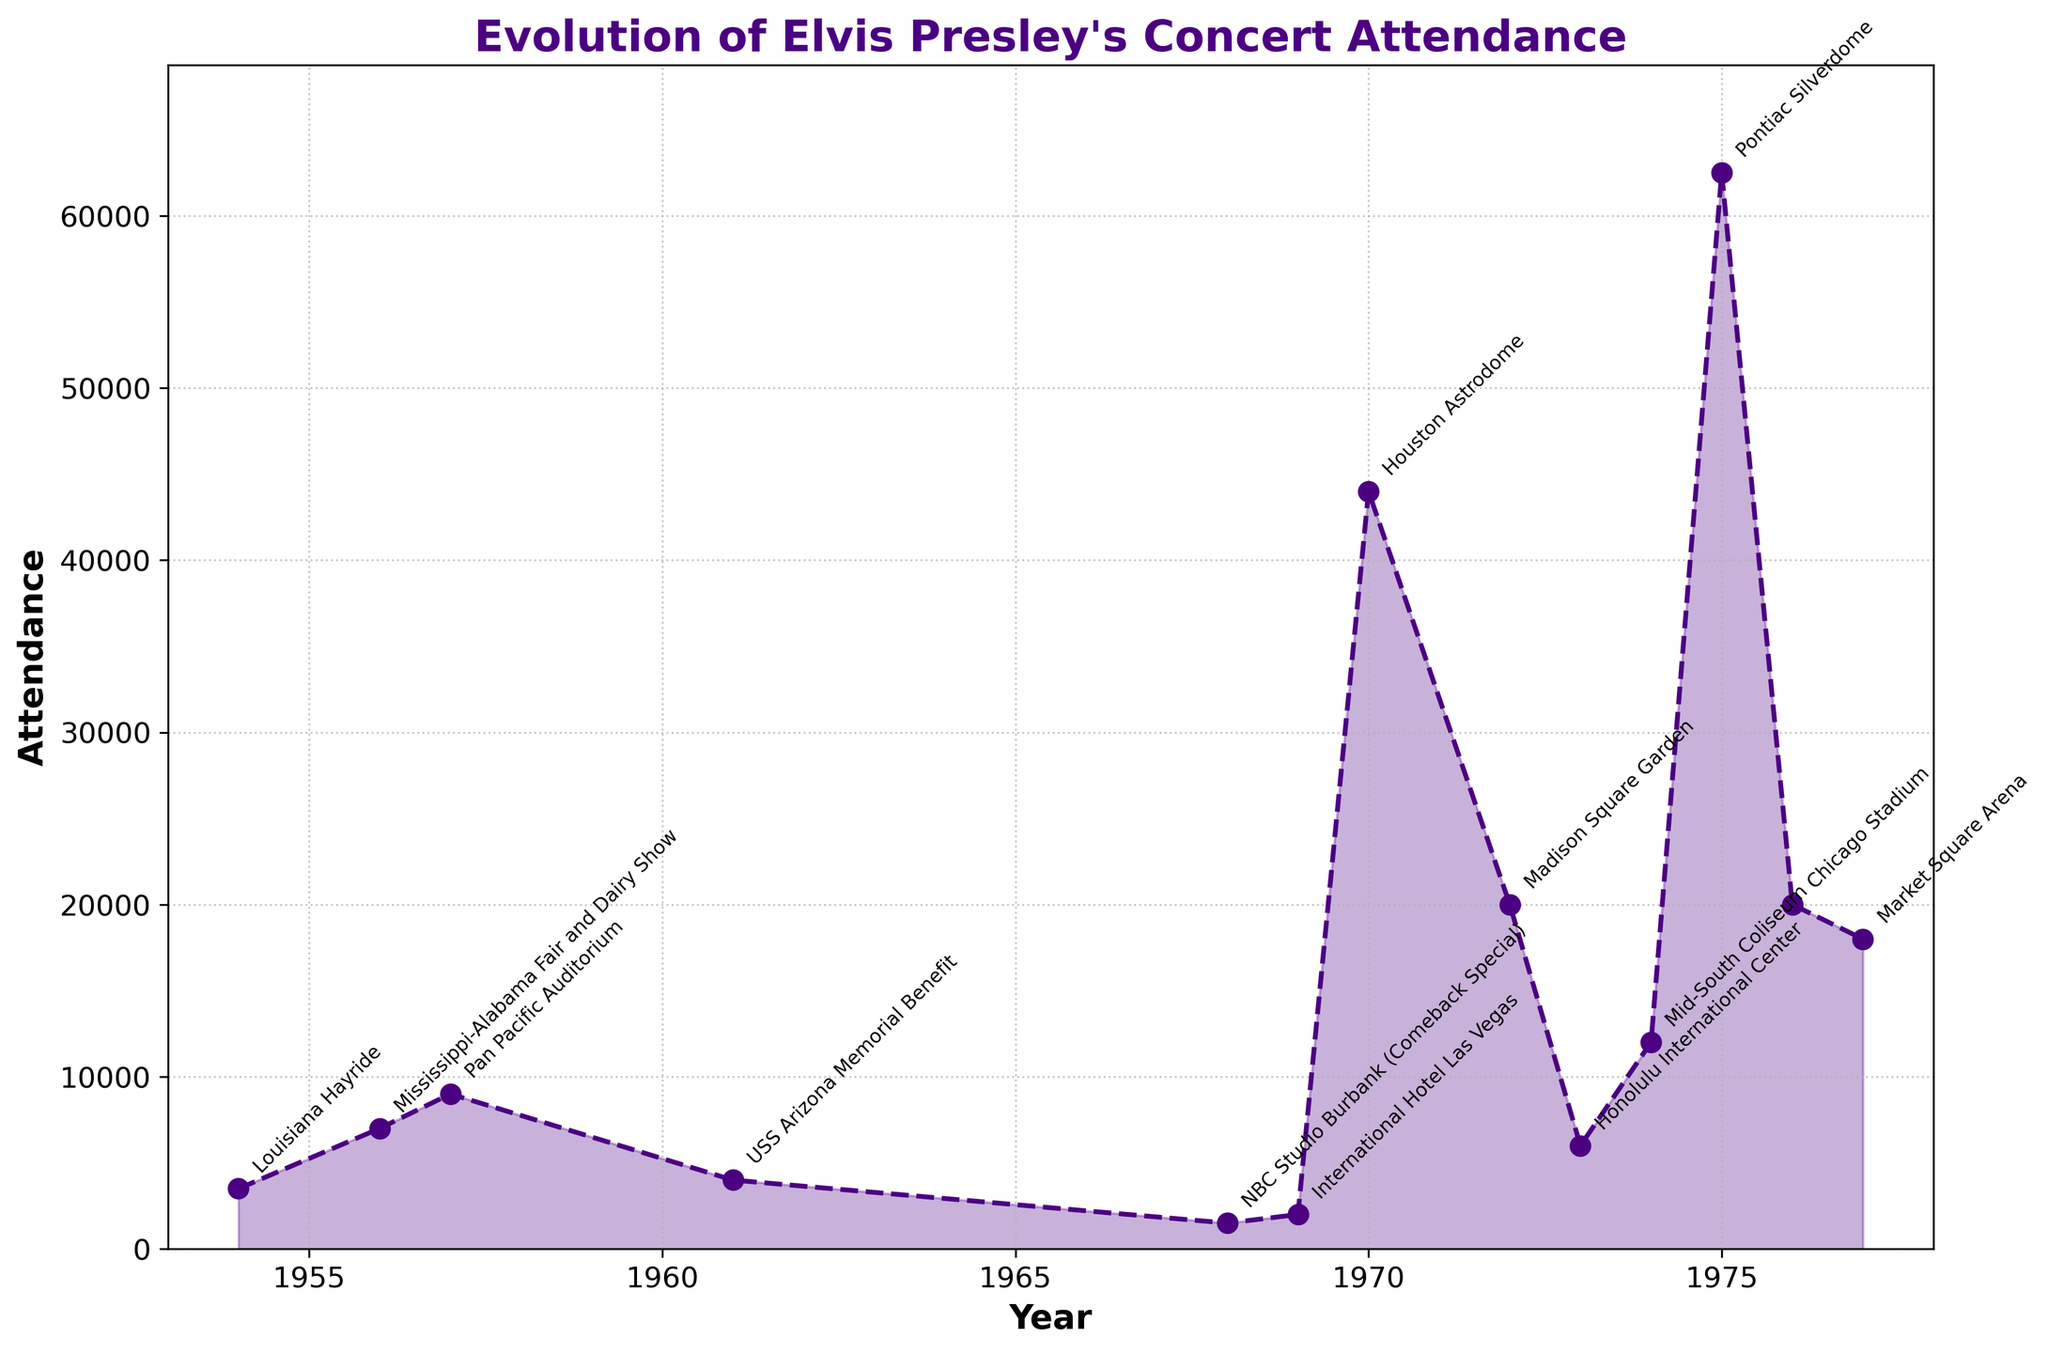What is the year with the highest concert attendance? The year with the highest concert attendance can be found by looking at the highest peak on the graph. The highest point is at 1975 with a value of 62,500.
Answer: 1975 Which concert venue had the highest attendance? You can identify the concert venue with the highest attendance by finding the label closest to the highest peak on the chart. The label at the highest peak is 'Pontiac Silverdome'.
Answer: Pontiac Silverdome What was the attendance at the Houston Astrodome concert in 1970? To find the attendance at the Houston Astrodome concert, locate the year 1970 on the x-axis and read the corresponding y-axis value. The attendance at that point is 44,000.
Answer: 44,000 Between which years did Elvis Presley’s concert attendance increase the most? Look for the steepest upward slope between two consecutive points on the graph. The steepest increase is seen between 1969 and 1970. The attendance increased from 2,000 to 44,000, an increase of 42,000.
Answer: Between 1969 and 1970 What is the average concert attendance from 1954 to 1977? To find the average concert attendance, sum all the attendance numbers from 1954 to 1977 and divide by the number of data points. The sum is 3500+7000+9000+4000+1500+2000+44000+20000+6000+12000+62500+20000+18000 = 222,000. There are 13 years, so the average is 222,000 / 13 = 17,076.9.
Answer: 17,076.9 Compare the concert attendance of 1956 and 1968. Which one had higher attendance and by how much? To compare the two years, find the attendance for both years. In 1956, the attendance was 7,000, and in 1968, it was 1,500. The difference is 7,000 - 1,500 = 5,500, with 1956 being higher.
Answer: 1956 by 5,500 What was the trend in the number of attendees from 1975 to 1977? Examine the line segment from 1975 to 1977. The attendance decreases from 62,500 in 1975 to 20,000 in 1976 and then to 18,000 in 1977. Therefore, the trend is a decrease in attendance.
Answer: Decreasing How many total years had concert attendance above 20,000? Count the number of peaks above the 20,000 mark on the y-axis. The years are 1970, 1975, 1976, and 1977. Therefore, 4 years had attendance above 20,000.
Answer: 4 What was the lowest concert attendance in Elvis’s career according to the chart? Identify the lowest point on the graph. The smallest value is 1,500 in the year 1968 at the NBC Studio Burbank (Comeback Special).
Answer: 1,500 